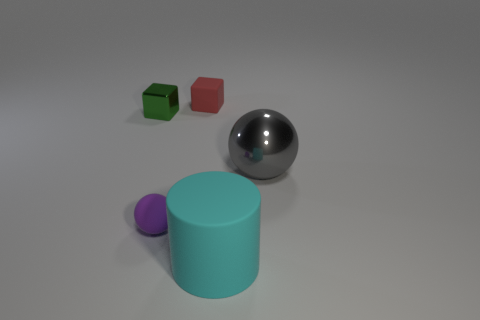Add 4 rubber balls. How many objects exist? 9 Subtract all cylinders. How many objects are left? 4 Subtract 0 yellow blocks. How many objects are left? 5 Subtract all big gray metal objects. Subtract all shiny spheres. How many objects are left? 3 Add 2 big shiny objects. How many big shiny objects are left? 3 Add 3 big cyan things. How many big cyan things exist? 4 